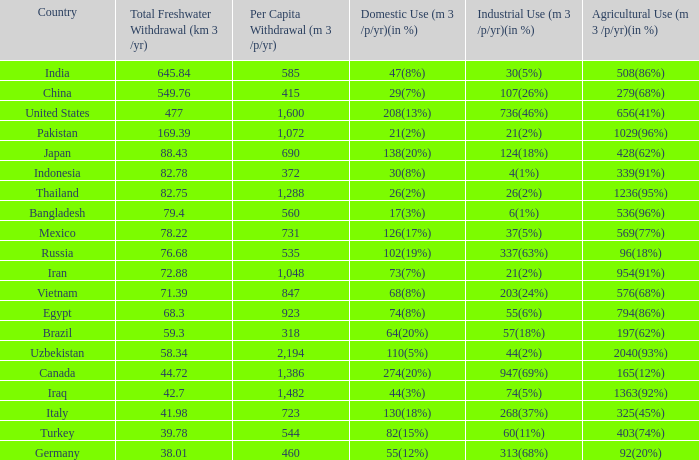If per capita withdrawal is more than 923 (m3/p/yr) and domestic use is 73 (7%), what is the percentage of agricultural use (m3/p/yr)? 954(91%). Can you give me this table as a dict? {'header': ['Country', 'Total Freshwater Withdrawal (km 3 /yr)', 'Per Capita Withdrawal (m 3 /p/yr)', 'Domestic Use (m 3 /p/yr)(in %)', 'Industrial Use (m 3 /p/yr)(in %)', 'Agricultural Use (m 3 /p/yr)(in %)'], 'rows': [['India', '645.84', '585', '47(8%)', '30(5%)', '508(86%)'], ['China', '549.76', '415', '29(7%)', '107(26%)', '279(68%)'], ['United States', '477', '1,600', '208(13%)', '736(46%)', '656(41%)'], ['Pakistan', '169.39', '1,072', '21(2%)', '21(2%)', '1029(96%)'], ['Japan', '88.43', '690', '138(20%)', '124(18%)', '428(62%)'], ['Indonesia', '82.78', '372', '30(8%)', '4(1%)', '339(91%)'], ['Thailand', '82.75', '1,288', '26(2%)', '26(2%)', '1236(95%)'], ['Bangladesh', '79.4', '560', '17(3%)', '6(1%)', '536(96%)'], ['Mexico', '78.22', '731', '126(17%)', '37(5%)', '569(77%)'], ['Russia', '76.68', '535', '102(19%)', '337(63%)', '96(18%)'], ['Iran', '72.88', '1,048', '73(7%)', '21(2%)', '954(91%)'], ['Vietnam', '71.39', '847', '68(8%)', '203(24%)', '576(68%)'], ['Egypt', '68.3', '923', '74(8%)', '55(6%)', '794(86%)'], ['Brazil', '59.3', '318', '64(20%)', '57(18%)', '197(62%)'], ['Uzbekistan', '58.34', '2,194', '110(5%)', '44(2%)', '2040(93%)'], ['Canada', '44.72', '1,386', '274(20%)', '947(69%)', '165(12%)'], ['Iraq', '42.7', '1,482', '44(3%)', '74(5%)', '1363(92%)'], ['Italy', '41.98', '723', '130(18%)', '268(37%)', '325(45%)'], ['Turkey', '39.78', '544', '82(15%)', '60(11%)', '403(74%)'], ['Germany', '38.01', '460', '55(12%)', '313(68%)', '92(20%)']]} 